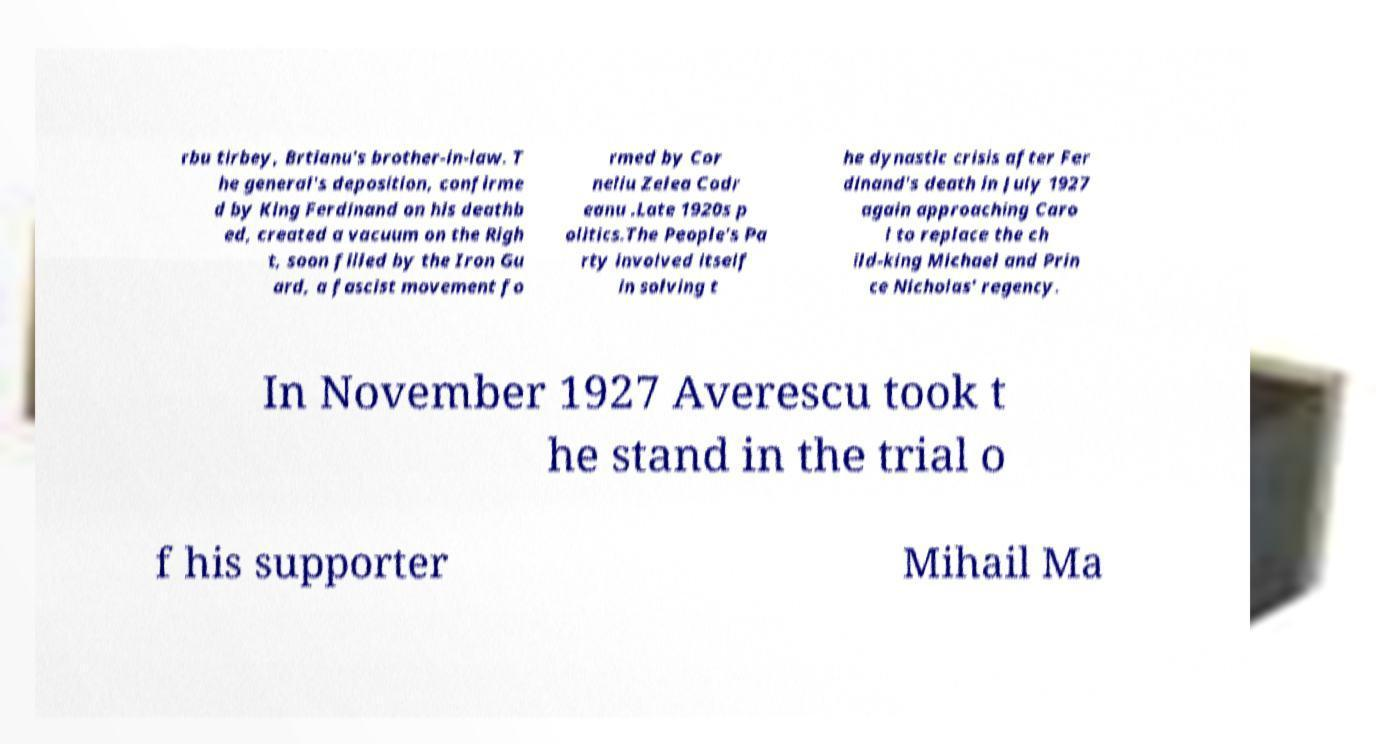Could you extract and type out the text from this image? rbu tirbey, Brtianu's brother-in-law. T he general's deposition, confirme d by King Ferdinand on his deathb ed, created a vacuum on the Righ t, soon filled by the Iron Gu ard, a fascist movement fo rmed by Cor neliu Zelea Codr eanu .Late 1920s p olitics.The People's Pa rty involved itself in solving t he dynastic crisis after Fer dinand's death in July 1927 again approaching Caro l to replace the ch ild-king Michael and Prin ce Nicholas' regency. In November 1927 Averescu took t he stand in the trial o f his supporter Mihail Ma 